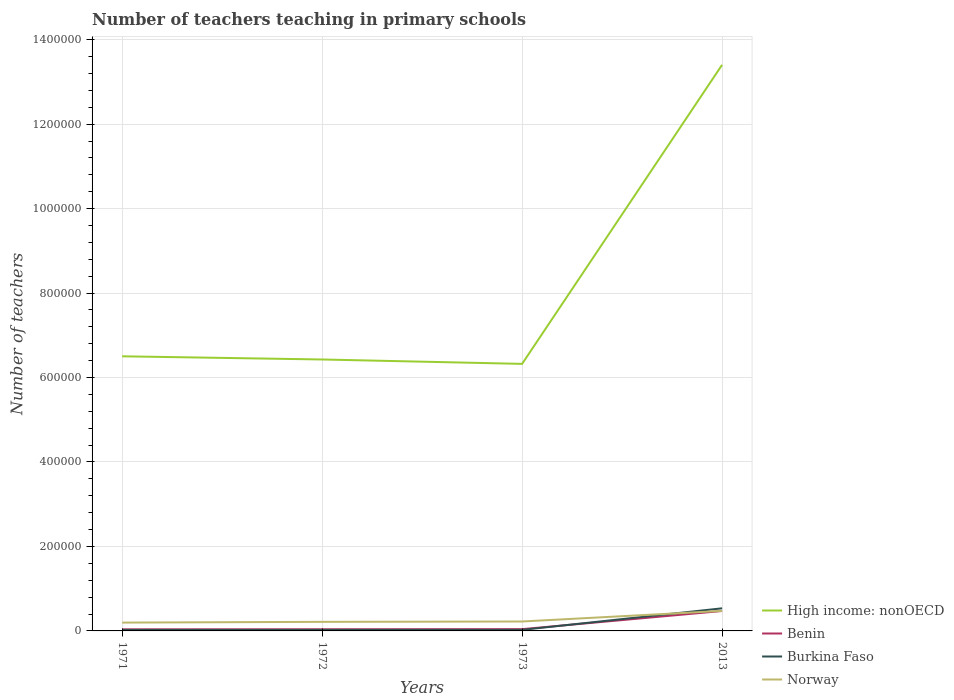Does the line corresponding to Benin intersect with the line corresponding to Norway?
Ensure brevity in your answer.  No. Is the number of lines equal to the number of legend labels?
Give a very brief answer. Yes. Across all years, what is the maximum number of teachers teaching in primary schools in High income: nonOECD?
Provide a succinct answer. 6.32e+05. In which year was the number of teachers teaching in primary schools in Benin maximum?
Make the answer very short. 1971. What is the total number of teachers teaching in primary schools in High income: nonOECD in the graph?
Keep it short and to the point. -7.08e+05. What is the difference between the highest and the second highest number of teachers teaching in primary schools in Burkina Faso?
Give a very brief answer. 5.11e+04. What is the difference between the highest and the lowest number of teachers teaching in primary schools in Burkina Faso?
Ensure brevity in your answer.  1. How many lines are there?
Your answer should be very brief. 4. What is the difference between two consecutive major ticks on the Y-axis?
Keep it short and to the point. 2.00e+05. Are the values on the major ticks of Y-axis written in scientific E-notation?
Ensure brevity in your answer.  No. Where does the legend appear in the graph?
Your response must be concise. Bottom right. How many legend labels are there?
Your response must be concise. 4. What is the title of the graph?
Your answer should be very brief. Number of teachers teaching in primary schools. Does "Middle income" appear as one of the legend labels in the graph?
Make the answer very short. No. What is the label or title of the Y-axis?
Make the answer very short. Number of teachers. What is the Number of teachers of High income: nonOECD in 1971?
Provide a short and direct response. 6.50e+05. What is the Number of teachers in Benin in 1971?
Your answer should be very brief. 3753. What is the Number of teachers of Burkina Faso in 1971?
Provide a short and direct response. 2370. What is the Number of teachers in Norway in 1971?
Offer a terse response. 1.97e+04. What is the Number of teachers of High income: nonOECD in 1972?
Provide a succinct answer. 6.43e+05. What is the Number of teachers in Benin in 1972?
Your response must be concise. 3929. What is the Number of teachers in Burkina Faso in 1972?
Provide a short and direct response. 2376. What is the Number of teachers in Norway in 1972?
Offer a very short reply. 2.15e+04. What is the Number of teachers in High income: nonOECD in 1973?
Ensure brevity in your answer.  6.32e+05. What is the Number of teachers in Benin in 1973?
Provide a short and direct response. 4184. What is the Number of teachers of Burkina Faso in 1973?
Offer a very short reply. 2492. What is the Number of teachers in Norway in 1973?
Provide a succinct answer. 2.23e+04. What is the Number of teachers in High income: nonOECD in 2013?
Make the answer very short. 1.34e+06. What is the Number of teachers of Benin in 2013?
Provide a short and direct response. 4.72e+04. What is the Number of teachers of Burkina Faso in 2013?
Your answer should be compact. 5.35e+04. What is the Number of teachers in Norway in 2013?
Make the answer very short. 4.74e+04. Across all years, what is the maximum Number of teachers of High income: nonOECD?
Provide a short and direct response. 1.34e+06. Across all years, what is the maximum Number of teachers in Benin?
Keep it short and to the point. 4.72e+04. Across all years, what is the maximum Number of teachers in Burkina Faso?
Your response must be concise. 5.35e+04. Across all years, what is the maximum Number of teachers of Norway?
Give a very brief answer. 4.74e+04. Across all years, what is the minimum Number of teachers of High income: nonOECD?
Ensure brevity in your answer.  6.32e+05. Across all years, what is the minimum Number of teachers in Benin?
Offer a very short reply. 3753. Across all years, what is the minimum Number of teachers in Burkina Faso?
Provide a short and direct response. 2370. Across all years, what is the minimum Number of teachers of Norway?
Make the answer very short. 1.97e+04. What is the total Number of teachers of High income: nonOECD in the graph?
Keep it short and to the point. 3.27e+06. What is the total Number of teachers in Benin in the graph?
Provide a short and direct response. 5.91e+04. What is the total Number of teachers of Burkina Faso in the graph?
Provide a short and direct response. 6.07e+04. What is the total Number of teachers in Norway in the graph?
Provide a short and direct response. 1.11e+05. What is the difference between the Number of teachers in High income: nonOECD in 1971 and that in 1972?
Give a very brief answer. 7545.62. What is the difference between the Number of teachers in Benin in 1971 and that in 1972?
Offer a very short reply. -176. What is the difference between the Number of teachers in Burkina Faso in 1971 and that in 1972?
Your answer should be very brief. -6. What is the difference between the Number of teachers in Norway in 1971 and that in 1972?
Ensure brevity in your answer.  -1776. What is the difference between the Number of teachers in High income: nonOECD in 1971 and that in 1973?
Ensure brevity in your answer.  1.79e+04. What is the difference between the Number of teachers in Benin in 1971 and that in 1973?
Give a very brief answer. -431. What is the difference between the Number of teachers in Burkina Faso in 1971 and that in 1973?
Give a very brief answer. -122. What is the difference between the Number of teachers of Norway in 1971 and that in 1973?
Keep it short and to the point. -2590. What is the difference between the Number of teachers of High income: nonOECD in 1971 and that in 2013?
Make the answer very short. -6.90e+05. What is the difference between the Number of teachers of Benin in 1971 and that in 2013?
Give a very brief answer. -4.34e+04. What is the difference between the Number of teachers in Burkina Faso in 1971 and that in 2013?
Keep it short and to the point. -5.11e+04. What is the difference between the Number of teachers of Norway in 1971 and that in 2013?
Keep it short and to the point. -2.77e+04. What is the difference between the Number of teachers of High income: nonOECD in 1972 and that in 1973?
Provide a succinct answer. 1.04e+04. What is the difference between the Number of teachers of Benin in 1972 and that in 1973?
Provide a short and direct response. -255. What is the difference between the Number of teachers in Burkina Faso in 1972 and that in 1973?
Keep it short and to the point. -116. What is the difference between the Number of teachers in Norway in 1972 and that in 1973?
Your answer should be compact. -814. What is the difference between the Number of teachers in High income: nonOECD in 1972 and that in 2013?
Give a very brief answer. -6.98e+05. What is the difference between the Number of teachers of Benin in 1972 and that in 2013?
Provide a short and direct response. -4.33e+04. What is the difference between the Number of teachers of Burkina Faso in 1972 and that in 2013?
Keep it short and to the point. -5.11e+04. What is the difference between the Number of teachers in Norway in 1972 and that in 2013?
Offer a terse response. -2.60e+04. What is the difference between the Number of teachers in High income: nonOECD in 1973 and that in 2013?
Your answer should be compact. -7.08e+05. What is the difference between the Number of teachers of Benin in 1973 and that in 2013?
Your response must be concise. -4.30e+04. What is the difference between the Number of teachers in Burkina Faso in 1973 and that in 2013?
Your answer should be very brief. -5.10e+04. What is the difference between the Number of teachers in Norway in 1973 and that in 2013?
Your answer should be compact. -2.51e+04. What is the difference between the Number of teachers of High income: nonOECD in 1971 and the Number of teachers of Benin in 1972?
Ensure brevity in your answer.  6.46e+05. What is the difference between the Number of teachers of High income: nonOECD in 1971 and the Number of teachers of Burkina Faso in 1972?
Make the answer very short. 6.48e+05. What is the difference between the Number of teachers in High income: nonOECD in 1971 and the Number of teachers in Norway in 1972?
Your answer should be compact. 6.29e+05. What is the difference between the Number of teachers in Benin in 1971 and the Number of teachers in Burkina Faso in 1972?
Make the answer very short. 1377. What is the difference between the Number of teachers of Benin in 1971 and the Number of teachers of Norway in 1972?
Offer a very short reply. -1.77e+04. What is the difference between the Number of teachers in Burkina Faso in 1971 and the Number of teachers in Norway in 1972?
Make the answer very short. -1.91e+04. What is the difference between the Number of teachers of High income: nonOECD in 1971 and the Number of teachers of Benin in 1973?
Your response must be concise. 6.46e+05. What is the difference between the Number of teachers of High income: nonOECD in 1971 and the Number of teachers of Burkina Faso in 1973?
Your answer should be compact. 6.48e+05. What is the difference between the Number of teachers of High income: nonOECD in 1971 and the Number of teachers of Norway in 1973?
Your response must be concise. 6.28e+05. What is the difference between the Number of teachers in Benin in 1971 and the Number of teachers in Burkina Faso in 1973?
Your answer should be very brief. 1261. What is the difference between the Number of teachers of Benin in 1971 and the Number of teachers of Norway in 1973?
Provide a short and direct response. -1.86e+04. What is the difference between the Number of teachers in Burkina Faso in 1971 and the Number of teachers in Norway in 1973?
Offer a terse response. -1.99e+04. What is the difference between the Number of teachers of High income: nonOECD in 1971 and the Number of teachers of Benin in 2013?
Your answer should be very brief. 6.03e+05. What is the difference between the Number of teachers of High income: nonOECD in 1971 and the Number of teachers of Burkina Faso in 2013?
Provide a succinct answer. 5.97e+05. What is the difference between the Number of teachers in High income: nonOECD in 1971 and the Number of teachers in Norway in 2013?
Make the answer very short. 6.03e+05. What is the difference between the Number of teachers in Benin in 1971 and the Number of teachers in Burkina Faso in 2013?
Make the answer very short. -4.98e+04. What is the difference between the Number of teachers of Benin in 1971 and the Number of teachers of Norway in 2013?
Offer a very short reply. -4.37e+04. What is the difference between the Number of teachers in Burkina Faso in 1971 and the Number of teachers in Norway in 2013?
Keep it short and to the point. -4.51e+04. What is the difference between the Number of teachers of High income: nonOECD in 1972 and the Number of teachers of Benin in 1973?
Your response must be concise. 6.39e+05. What is the difference between the Number of teachers in High income: nonOECD in 1972 and the Number of teachers in Burkina Faso in 1973?
Make the answer very short. 6.40e+05. What is the difference between the Number of teachers of High income: nonOECD in 1972 and the Number of teachers of Norway in 1973?
Your answer should be compact. 6.20e+05. What is the difference between the Number of teachers in Benin in 1972 and the Number of teachers in Burkina Faso in 1973?
Your answer should be very brief. 1437. What is the difference between the Number of teachers in Benin in 1972 and the Number of teachers in Norway in 1973?
Keep it short and to the point. -1.84e+04. What is the difference between the Number of teachers of Burkina Faso in 1972 and the Number of teachers of Norway in 1973?
Ensure brevity in your answer.  -1.99e+04. What is the difference between the Number of teachers in High income: nonOECD in 1972 and the Number of teachers in Benin in 2013?
Your response must be concise. 5.96e+05. What is the difference between the Number of teachers in High income: nonOECD in 1972 and the Number of teachers in Burkina Faso in 2013?
Your answer should be compact. 5.89e+05. What is the difference between the Number of teachers of High income: nonOECD in 1972 and the Number of teachers of Norway in 2013?
Your response must be concise. 5.95e+05. What is the difference between the Number of teachers in Benin in 1972 and the Number of teachers in Burkina Faso in 2013?
Keep it short and to the point. -4.96e+04. What is the difference between the Number of teachers in Benin in 1972 and the Number of teachers in Norway in 2013?
Your answer should be compact. -4.35e+04. What is the difference between the Number of teachers of Burkina Faso in 1972 and the Number of teachers of Norway in 2013?
Make the answer very short. -4.51e+04. What is the difference between the Number of teachers of High income: nonOECD in 1973 and the Number of teachers of Benin in 2013?
Make the answer very short. 5.85e+05. What is the difference between the Number of teachers in High income: nonOECD in 1973 and the Number of teachers in Burkina Faso in 2013?
Offer a very short reply. 5.79e+05. What is the difference between the Number of teachers of High income: nonOECD in 1973 and the Number of teachers of Norway in 2013?
Ensure brevity in your answer.  5.85e+05. What is the difference between the Number of teachers in Benin in 1973 and the Number of teachers in Burkina Faso in 2013?
Your answer should be very brief. -4.93e+04. What is the difference between the Number of teachers of Benin in 1973 and the Number of teachers of Norway in 2013?
Your response must be concise. -4.33e+04. What is the difference between the Number of teachers in Burkina Faso in 1973 and the Number of teachers in Norway in 2013?
Give a very brief answer. -4.50e+04. What is the average Number of teachers in High income: nonOECD per year?
Ensure brevity in your answer.  8.16e+05. What is the average Number of teachers in Benin per year?
Keep it short and to the point. 1.48e+04. What is the average Number of teachers of Burkina Faso per year?
Provide a succinct answer. 1.52e+04. What is the average Number of teachers of Norway per year?
Your answer should be compact. 2.77e+04. In the year 1971, what is the difference between the Number of teachers in High income: nonOECD and Number of teachers in Benin?
Make the answer very short. 6.47e+05. In the year 1971, what is the difference between the Number of teachers of High income: nonOECD and Number of teachers of Burkina Faso?
Provide a succinct answer. 6.48e+05. In the year 1971, what is the difference between the Number of teachers in High income: nonOECD and Number of teachers in Norway?
Offer a very short reply. 6.31e+05. In the year 1971, what is the difference between the Number of teachers of Benin and Number of teachers of Burkina Faso?
Your response must be concise. 1383. In the year 1971, what is the difference between the Number of teachers in Benin and Number of teachers in Norway?
Your answer should be very brief. -1.60e+04. In the year 1971, what is the difference between the Number of teachers of Burkina Faso and Number of teachers of Norway?
Offer a very short reply. -1.73e+04. In the year 1972, what is the difference between the Number of teachers of High income: nonOECD and Number of teachers of Benin?
Offer a terse response. 6.39e+05. In the year 1972, what is the difference between the Number of teachers of High income: nonOECD and Number of teachers of Burkina Faso?
Keep it short and to the point. 6.40e+05. In the year 1972, what is the difference between the Number of teachers of High income: nonOECD and Number of teachers of Norway?
Offer a terse response. 6.21e+05. In the year 1972, what is the difference between the Number of teachers in Benin and Number of teachers in Burkina Faso?
Give a very brief answer. 1553. In the year 1972, what is the difference between the Number of teachers of Benin and Number of teachers of Norway?
Ensure brevity in your answer.  -1.76e+04. In the year 1972, what is the difference between the Number of teachers of Burkina Faso and Number of teachers of Norway?
Offer a very short reply. -1.91e+04. In the year 1973, what is the difference between the Number of teachers of High income: nonOECD and Number of teachers of Benin?
Give a very brief answer. 6.28e+05. In the year 1973, what is the difference between the Number of teachers in High income: nonOECD and Number of teachers in Burkina Faso?
Make the answer very short. 6.30e+05. In the year 1973, what is the difference between the Number of teachers in High income: nonOECD and Number of teachers in Norway?
Provide a short and direct response. 6.10e+05. In the year 1973, what is the difference between the Number of teachers of Benin and Number of teachers of Burkina Faso?
Offer a terse response. 1692. In the year 1973, what is the difference between the Number of teachers in Benin and Number of teachers in Norway?
Make the answer very short. -1.81e+04. In the year 1973, what is the difference between the Number of teachers in Burkina Faso and Number of teachers in Norway?
Offer a very short reply. -1.98e+04. In the year 2013, what is the difference between the Number of teachers of High income: nonOECD and Number of teachers of Benin?
Your answer should be very brief. 1.29e+06. In the year 2013, what is the difference between the Number of teachers in High income: nonOECD and Number of teachers in Burkina Faso?
Your answer should be very brief. 1.29e+06. In the year 2013, what is the difference between the Number of teachers of High income: nonOECD and Number of teachers of Norway?
Offer a very short reply. 1.29e+06. In the year 2013, what is the difference between the Number of teachers in Benin and Number of teachers in Burkina Faso?
Ensure brevity in your answer.  -6304. In the year 2013, what is the difference between the Number of teachers of Benin and Number of teachers of Norway?
Give a very brief answer. -243. In the year 2013, what is the difference between the Number of teachers of Burkina Faso and Number of teachers of Norway?
Provide a short and direct response. 6061. What is the ratio of the Number of teachers in High income: nonOECD in 1971 to that in 1972?
Offer a terse response. 1.01. What is the ratio of the Number of teachers of Benin in 1971 to that in 1972?
Offer a very short reply. 0.96. What is the ratio of the Number of teachers in Burkina Faso in 1971 to that in 1972?
Offer a terse response. 1. What is the ratio of the Number of teachers in Norway in 1971 to that in 1972?
Your response must be concise. 0.92. What is the ratio of the Number of teachers of High income: nonOECD in 1971 to that in 1973?
Your response must be concise. 1.03. What is the ratio of the Number of teachers of Benin in 1971 to that in 1973?
Your answer should be very brief. 0.9. What is the ratio of the Number of teachers of Burkina Faso in 1971 to that in 1973?
Provide a short and direct response. 0.95. What is the ratio of the Number of teachers in Norway in 1971 to that in 1973?
Make the answer very short. 0.88. What is the ratio of the Number of teachers in High income: nonOECD in 1971 to that in 2013?
Provide a succinct answer. 0.49. What is the ratio of the Number of teachers of Benin in 1971 to that in 2013?
Keep it short and to the point. 0.08. What is the ratio of the Number of teachers of Burkina Faso in 1971 to that in 2013?
Offer a terse response. 0.04. What is the ratio of the Number of teachers of Norway in 1971 to that in 2013?
Your response must be concise. 0.42. What is the ratio of the Number of teachers in High income: nonOECD in 1972 to that in 1973?
Offer a terse response. 1.02. What is the ratio of the Number of teachers in Benin in 1972 to that in 1973?
Offer a terse response. 0.94. What is the ratio of the Number of teachers of Burkina Faso in 1972 to that in 1973?
Provide a short and direct response. 0.95. What is the ratio of the Number of teachers of Norway in 1972 to that in 1973?
Offer a terse response. 0.96. What is the ratio of the Number of teachers of High income: nonOECD in 1972 to that in 2013?
Give a very brief answer. 0.48. What is the ratio of the Number of teachers of Benin in 1972 to that in 2013?
Give a very brief answer. 0.08. What is the ratio of the Number of teachers in Burkina Faso in 1972 to that in 2013?
Give a very brief answer. 0.04. What is the ratio of the Number of teachers in Norway in 1972 to that in 2013?
Your answer should be very brief. 0.45. What is the ratio of the Number of teachers in High income: nonOECD in 1973 to that in 2013?
Your answer should be compact. 0.47. What is the ratio of the Number of teachers in Benin in 1973 to that in 2013?
Provide a short and direct response. 0.09. What is the ratio of the Number of teachers in Burkina Faso in 1973 to that in 2013?
Provide a succinct answer. 0.05. What is the ratio of the Number of teachers in Norway in 1973 to that in 2013?
Offer a very short reply. 0.47. What is the difference between the highest and the second highest Number of teachers of High income: nonOECD?
Keep it short and to the point. 6.90e+05. What is the difference between the highest and the second highest Number of teachers in Benin?
Your answer should be compact. 4.30e+04. What is the difference between the highest and the second highest Number of teachers in Burkina Faso?
Give a very brief answer. 5.10e+04. What is the difference between the highest and the second highest Number of teachers in Norway?
Offer a terse response. 2.51e+04. What is the difference between the highest and the lowest Number of teachers in High income: nonOECD?
Ensure brevity in your answer.  7.08e+05. What is the difference between the highest and the lowest Number of teachers in Benin?
Offer a very short reply. 4.34e+04. What is the difference between the highest and the lowest Number of teachers in Burkina Faso?
Provide a succinct answer. 5.11e+04. What is the difference between the highest and the lowest Number of teachers of Norway?
Provide a succinct answer. 2.77e+04. 